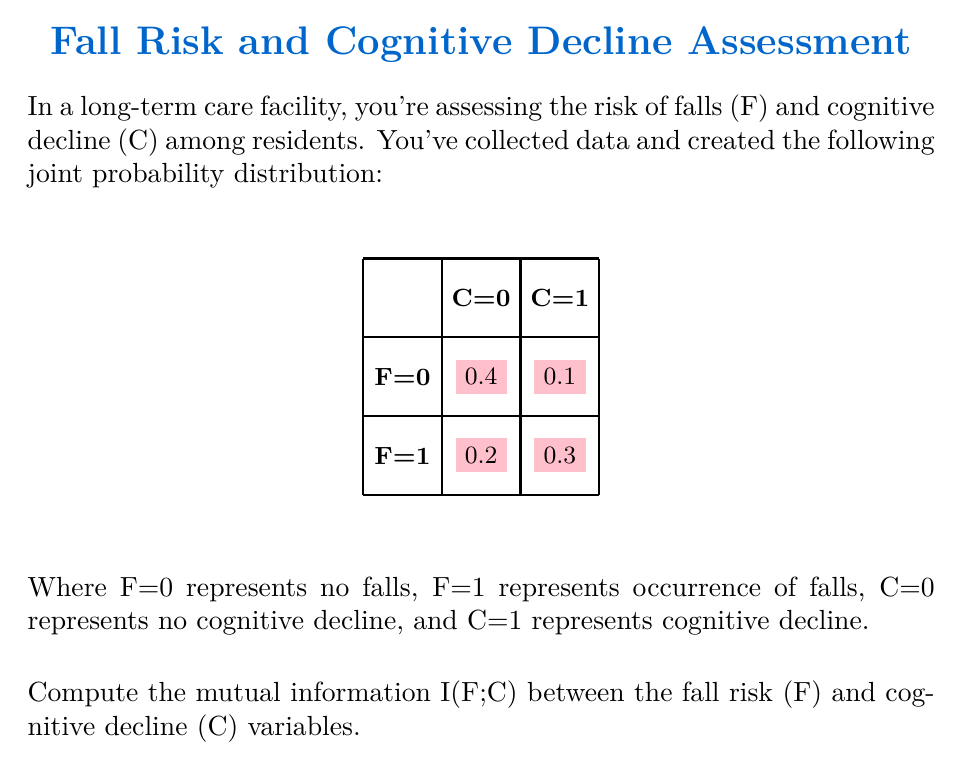What is the answer to this math problem? To compute the mutual information I(F;C), we'll follow these steps:

1) First, we need to calculate the marginal probabilities:
   P(F=0) = 0.4 + 0.1 = 0.5
   P(F=1) = 0.2 + 0.3 = 0.5
   P(C=0) = 0.4 + 0.2 = 0.6
   P(C=1) = 0.1 + 0.3 = 0.4

2) The formula for mutual information is:
   $$I(F;C) = \sum_{f\in F}\sum_{c\in C} P(f,c) \log_2\frac{P(f,c)}{P(f)P(c)}$$

3) Let's calculate each term:
   
   For F=0, C=0: $0.4 \log_2\frac{0.4}{0.5 \cdot 0.6} = 0.4 \log_2 1.3333 = 0.4155$
   
   For F=0, C=1: $0.1 \log_2\frac{0.1}{0.5 \cdot 0.4} = 0.1 \log_2 0.5 = -0.1$
   
   For F=1, C=0: $0.2 \log_2\frac{0.2}{0.5 \cdot 0.6} = 0.2 \log_2 0.6667 = -0.1037$
   
   For F=1, C=1: $0.3 \log_2\frac{0.3}{0.5 \cdot 0.4} = 0.3 \log_2 1.5 = 0.2108$

4) Sum all these terms:
   I(F;C) = 0.4155 + (-0.1) + (-0.1037) + 0.2108 = 0.4226 bits

This value represents the amount of information shared between the fall risk and cognitive decline variables in your risk assessment model.
Answer: 0.4226 bits 